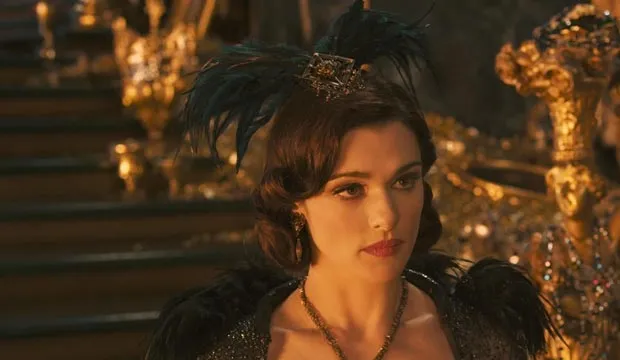Imagine this image is a scene from an epic fantasy movie. What would happen next? As the scene continues, the camera slowly zooms out to reveal the full grandeur of the throne room. Evanora, the central figure, is approached by a mysterious figure cloaked in shadow. This figure is a trusted advisor and holder of ancient secrets. They whisper urgent news into Evanora's ear about an impending threat to the kingdom. Without a moment to lose, Evanora orders her loyal guard to prepare for battle. The doors of the throne room swing open, revealing an army ready to defend their realm. The scene cuts to an epic battle montage, filled with magical duels, heroic feats, and the clash of swords. The fate of the kingdom hangs in the balance as Evanora leads her forces into the fray, her presence commanding and resolute. 